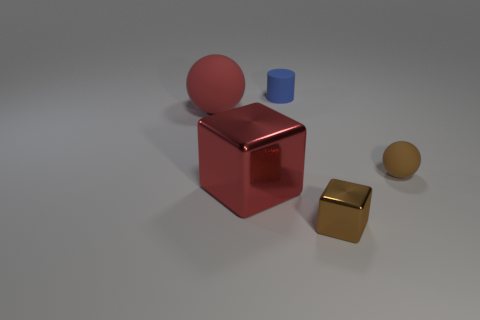Subtract all red cubes. How many cubes are left? 1 Add 2 large blue rubber things. How many objects exist? 7 Add 4 tiny objects. How many tiny objects are left? 7 Add 4 tiny blue metal spheres. How many tiny blue metal spheres exist? 4 Subtract 1 red balls. How many objects are left? 4 Subtract all spheres. How many objects are left? 3 Subtract 1 cylinders. How many cylinders are left? 0 Subtract all blue blocks. Subtract all yellow spheres. How many blocks are left? 2 Subtract all green cylinders. How many red cubes are left? 1 Subtract all blue matte cylinders. Subtract all small brown spheres. How many objects are left? 3 